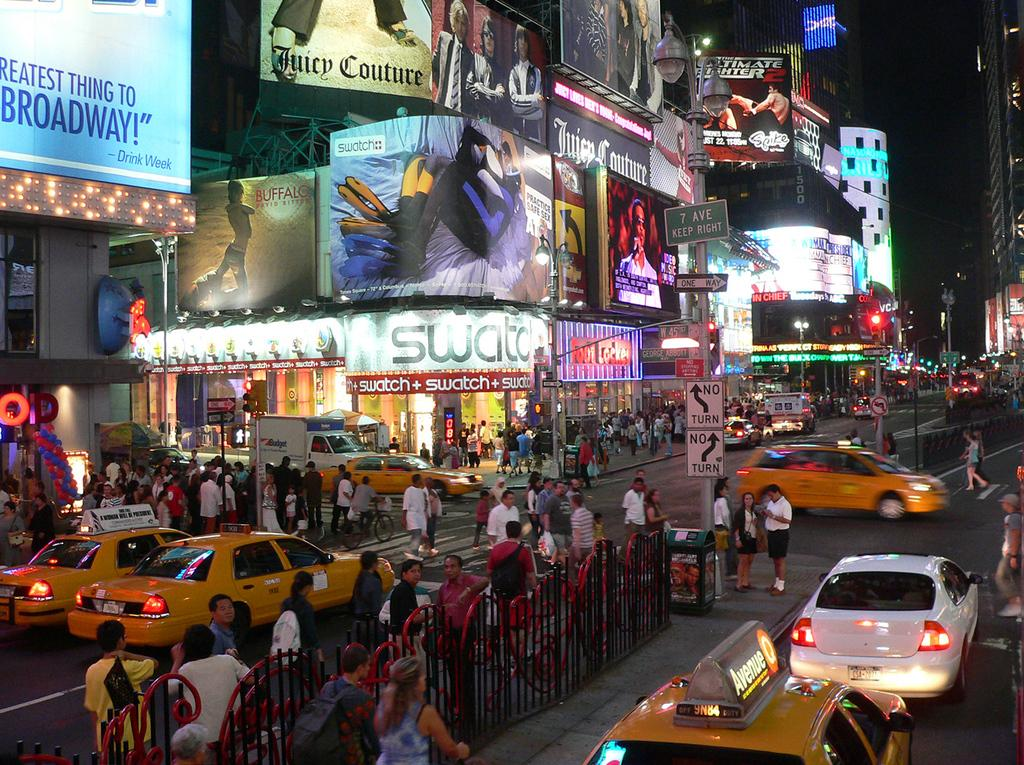<image>
Provide a brief description of the given image. The store with the white sign is Swatch 